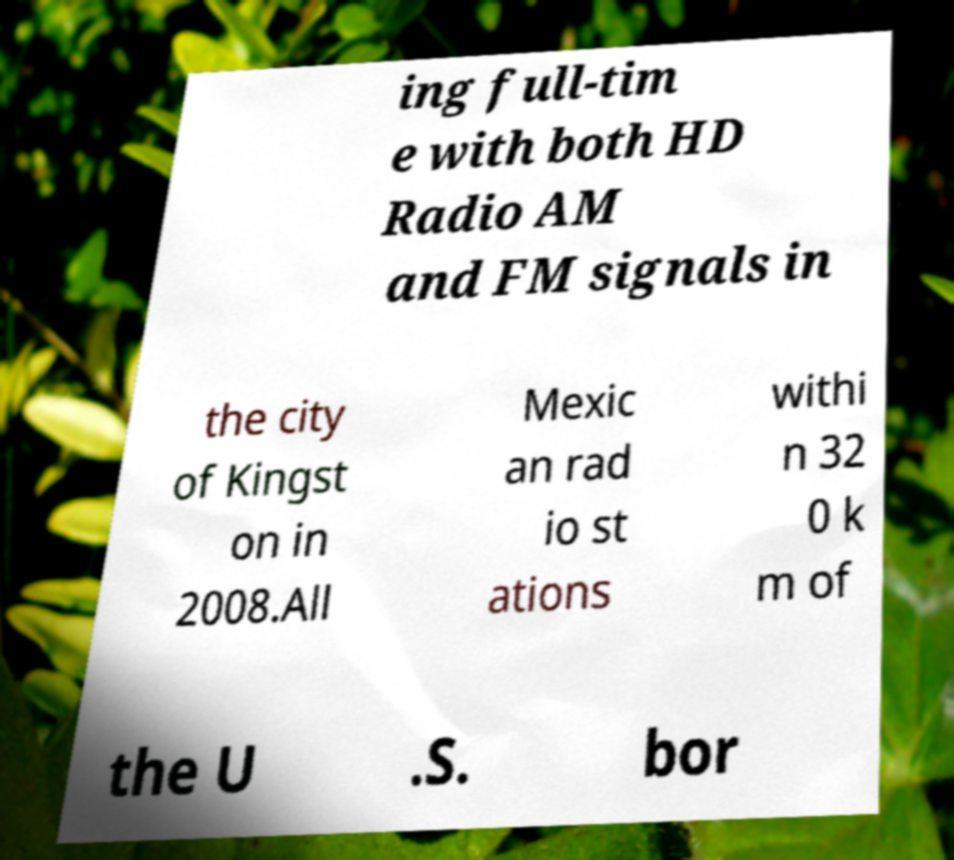I need the written content from this picture converted into text. Can you do that? ing full-tim e with both HD Radio AM and FM signals in the city of Kingst on in 2008.All Mexic an rad io st ations withi n 32 0 k m of the U .S. bor 